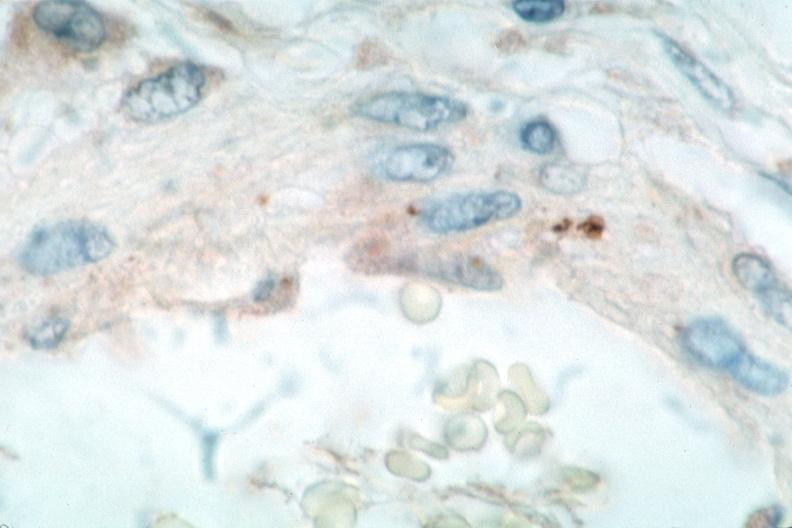s tuberculosis present?
Answer the question using a single word or phrase. No 